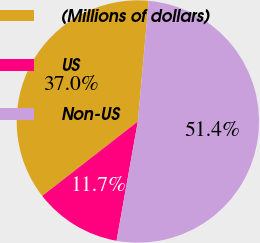Convert chart. <chart><loc_0><loc_0><loc_500><loc_500><pie_chart><fcel>(Millions of dollars)<fcel>US<fcel>Non-US<nl><fcel>36.95%<fcel>11.66%<fcel>51.39%<nl></chart> 